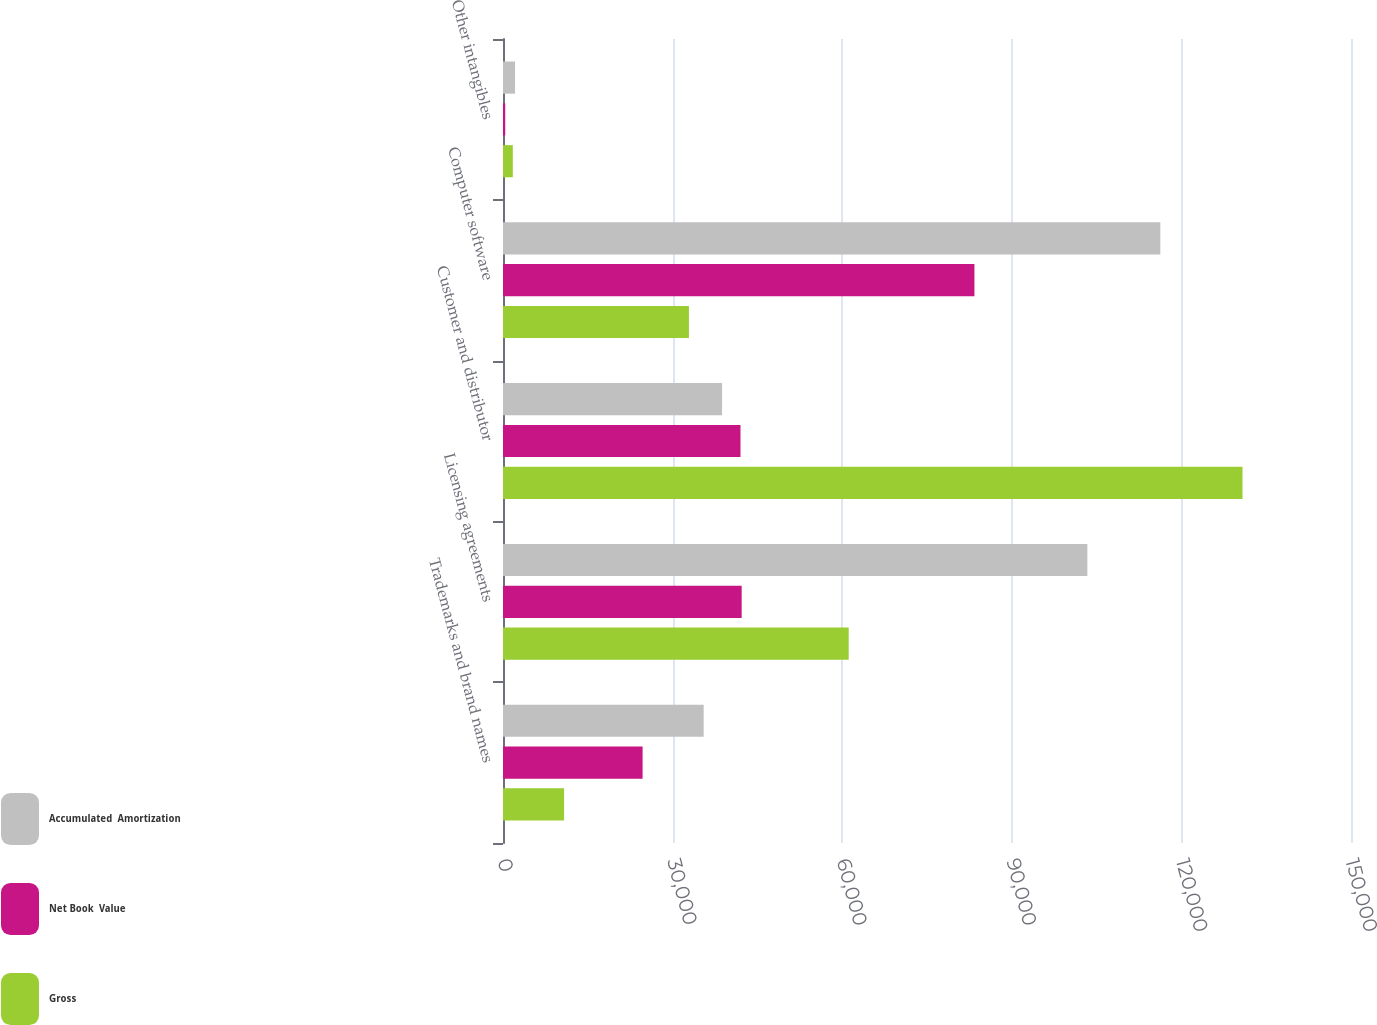Convert chart. <chart><loc_0><loc_0><loc_500><loc_500><stacked_bar_chart><ecel><fcel>Trademarks and brand names<fcel>Licensing agreements<fcel>Customer and distributor<fcel>Computer software<fcel>Other intangibles<nl><fcel>Accumulated  Amortization<fcel>35498<fcel>103366<fcel>38754<fcel>116273<fcel>2131<nl><fcel>Net Book  Value<fcel>24694<fcel>42218<fcel>42010<fcel>83390<fcel>397<nl><fcel>Gross<fcel>10804<fcel>61148<fcel>130810<fcel>32883<fcel>1734<nl></chart> 